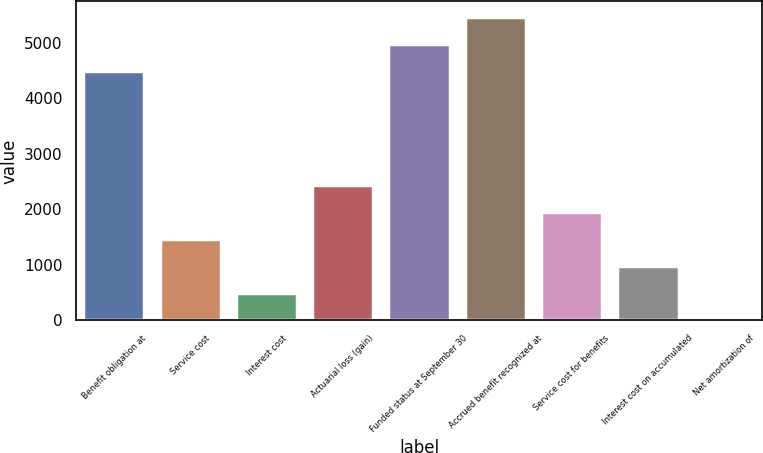Convert chart to OTSL. <chart><loc_0><loc_0><loc_500><loc_500><bar_chart><fcel>Benefit obligation at<fcel>Service cost<fcel>Interest cost<fcel>Actuarial loss (gain)<fcel>Funded status at September 30<fcel>Accrued benefit recognized at<fcel>Service cost for benefits<fcel>Interest cost on accumulated<fcel>Net amortization of<nl><fcel>4496.1<fcel>1469.3<fcel>491.1<fcel>2447.5<fcel>4985.2<fcel>5474.3<fcel>1958.4<fcel>980.2<fcel>2<nl></chart> 